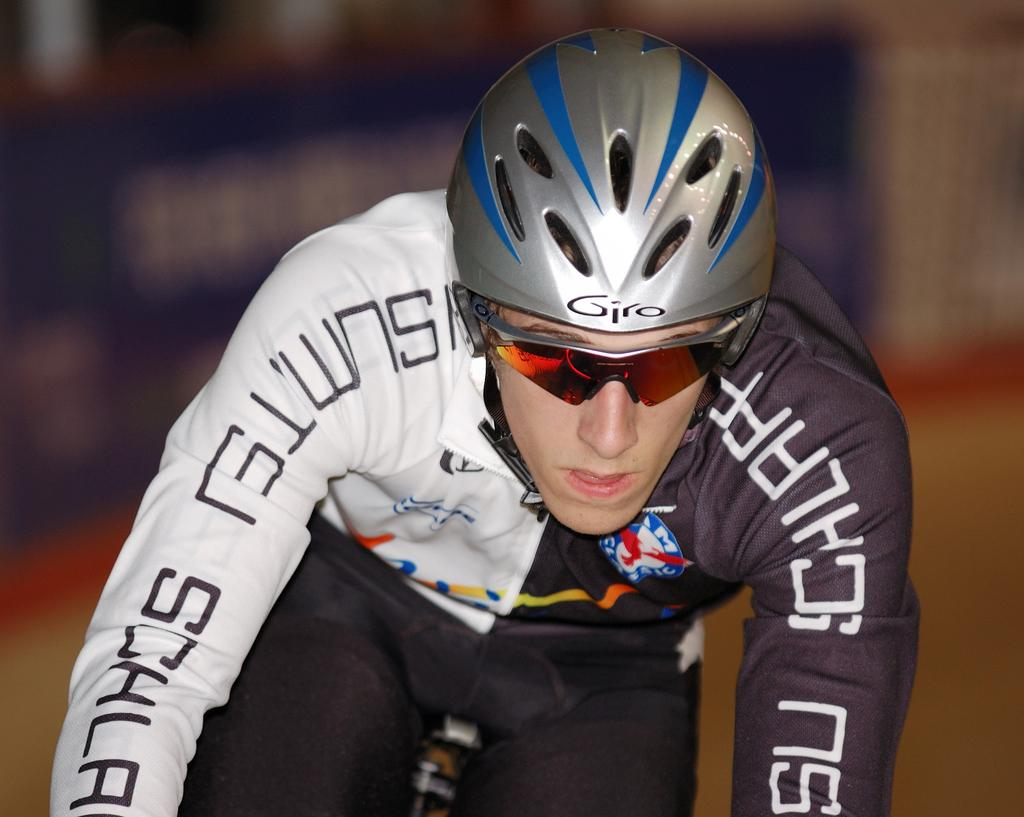What is the main subject of the image? There is a person in the image. What type of clothing is the person wearing? The person is wearing a sports dress, which is in white and black colors. What protective gear is the person wearing? The person is wearing a helmet and goggles. What activity is the person engaged in? The person is riding a bicycle. What type of doctor is the person in the image? The image does not depict a doctor; it shows a person riding a bicycle while wearing a sports dress, helmet, and goggles. Is the person in the image a carpenter? There is no indication in the image that the person is a carpenter; they are engaged in a cycling activity. 